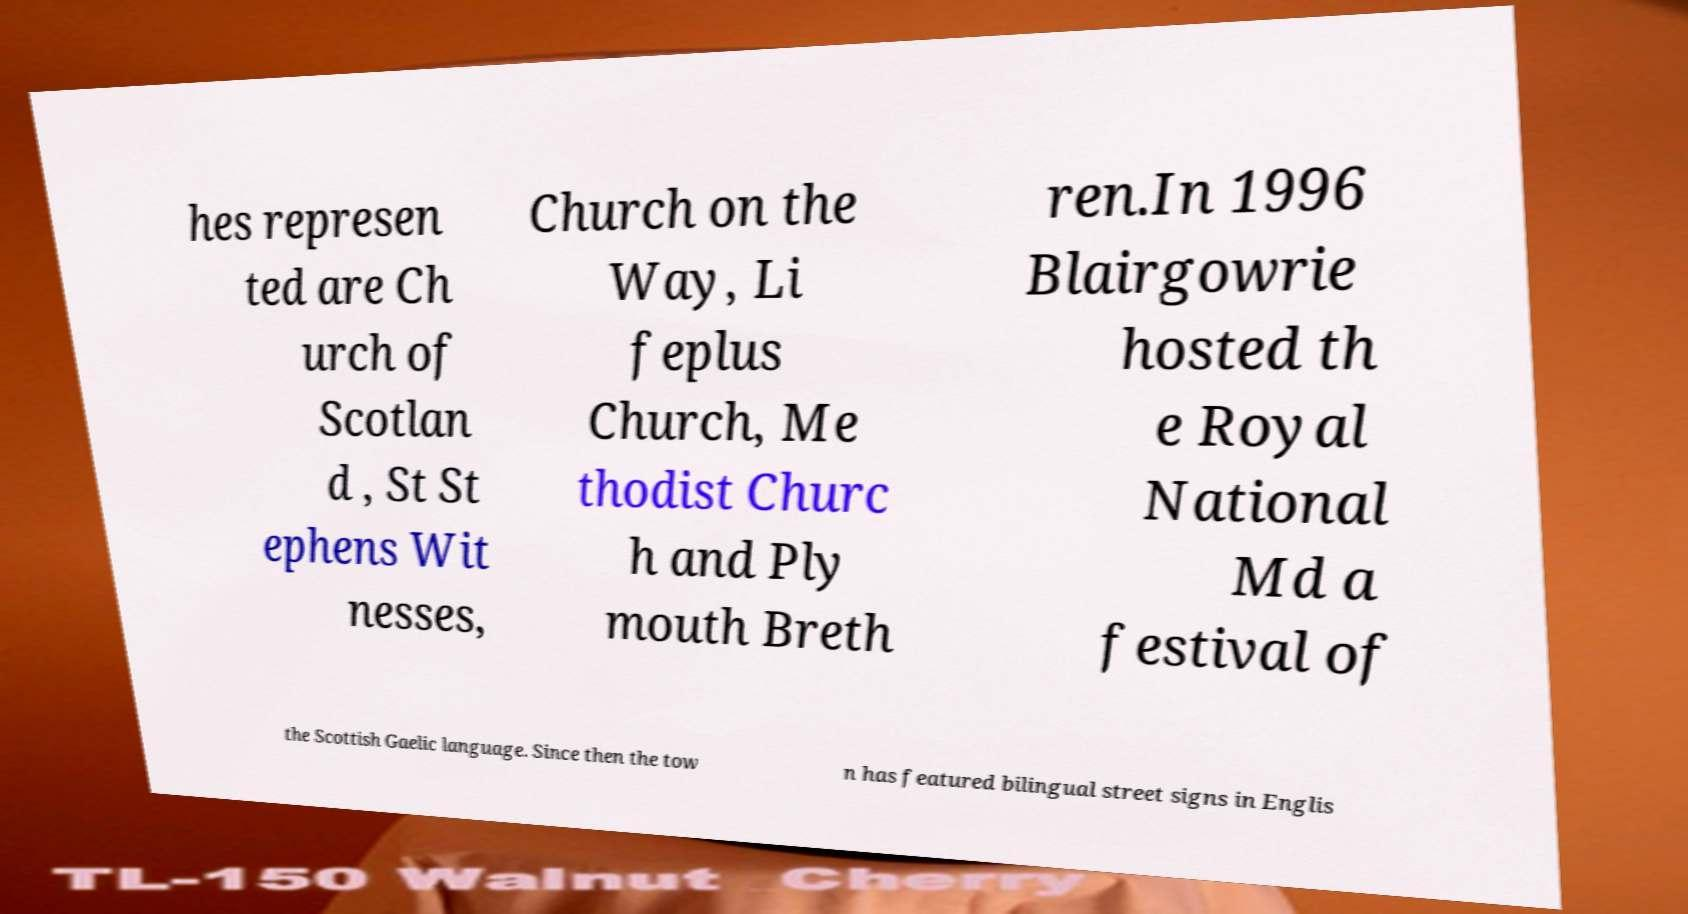Can you read and provide the text displayed in the image?This photo seems to have some interesting text. Can you extract and type it out for me? hes represen ted are Ch urch of Scotlan d , St St ephens Wit nesses, Church on the Way, Li feplus Church, Me thodist Churc h and Ply mouth Breth ren.In 1996 Blairgowrie hosted th e Royal National Md a festival of the Scottish Gaelic language. Since then the tow n has featured bilingual street signs in Englis 